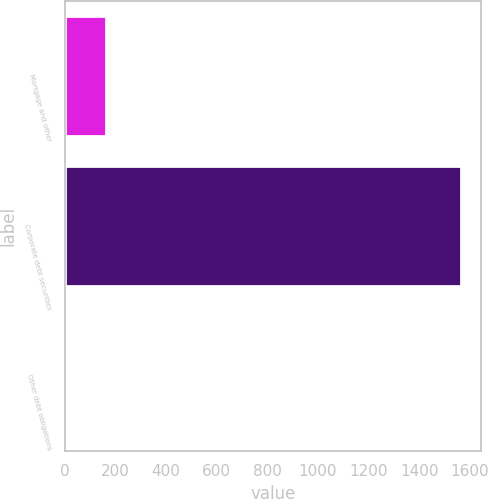Convert chart to OTSL. <chart><loc_0><loc_0><loc_500><loc_500><bar_chart><fcel>Mortgage and other<fcel>Corporate debt securities<fcel>Other debt obligations<nl><fcel>161.2<fcel>1567<fcel>5<nl></chart> 